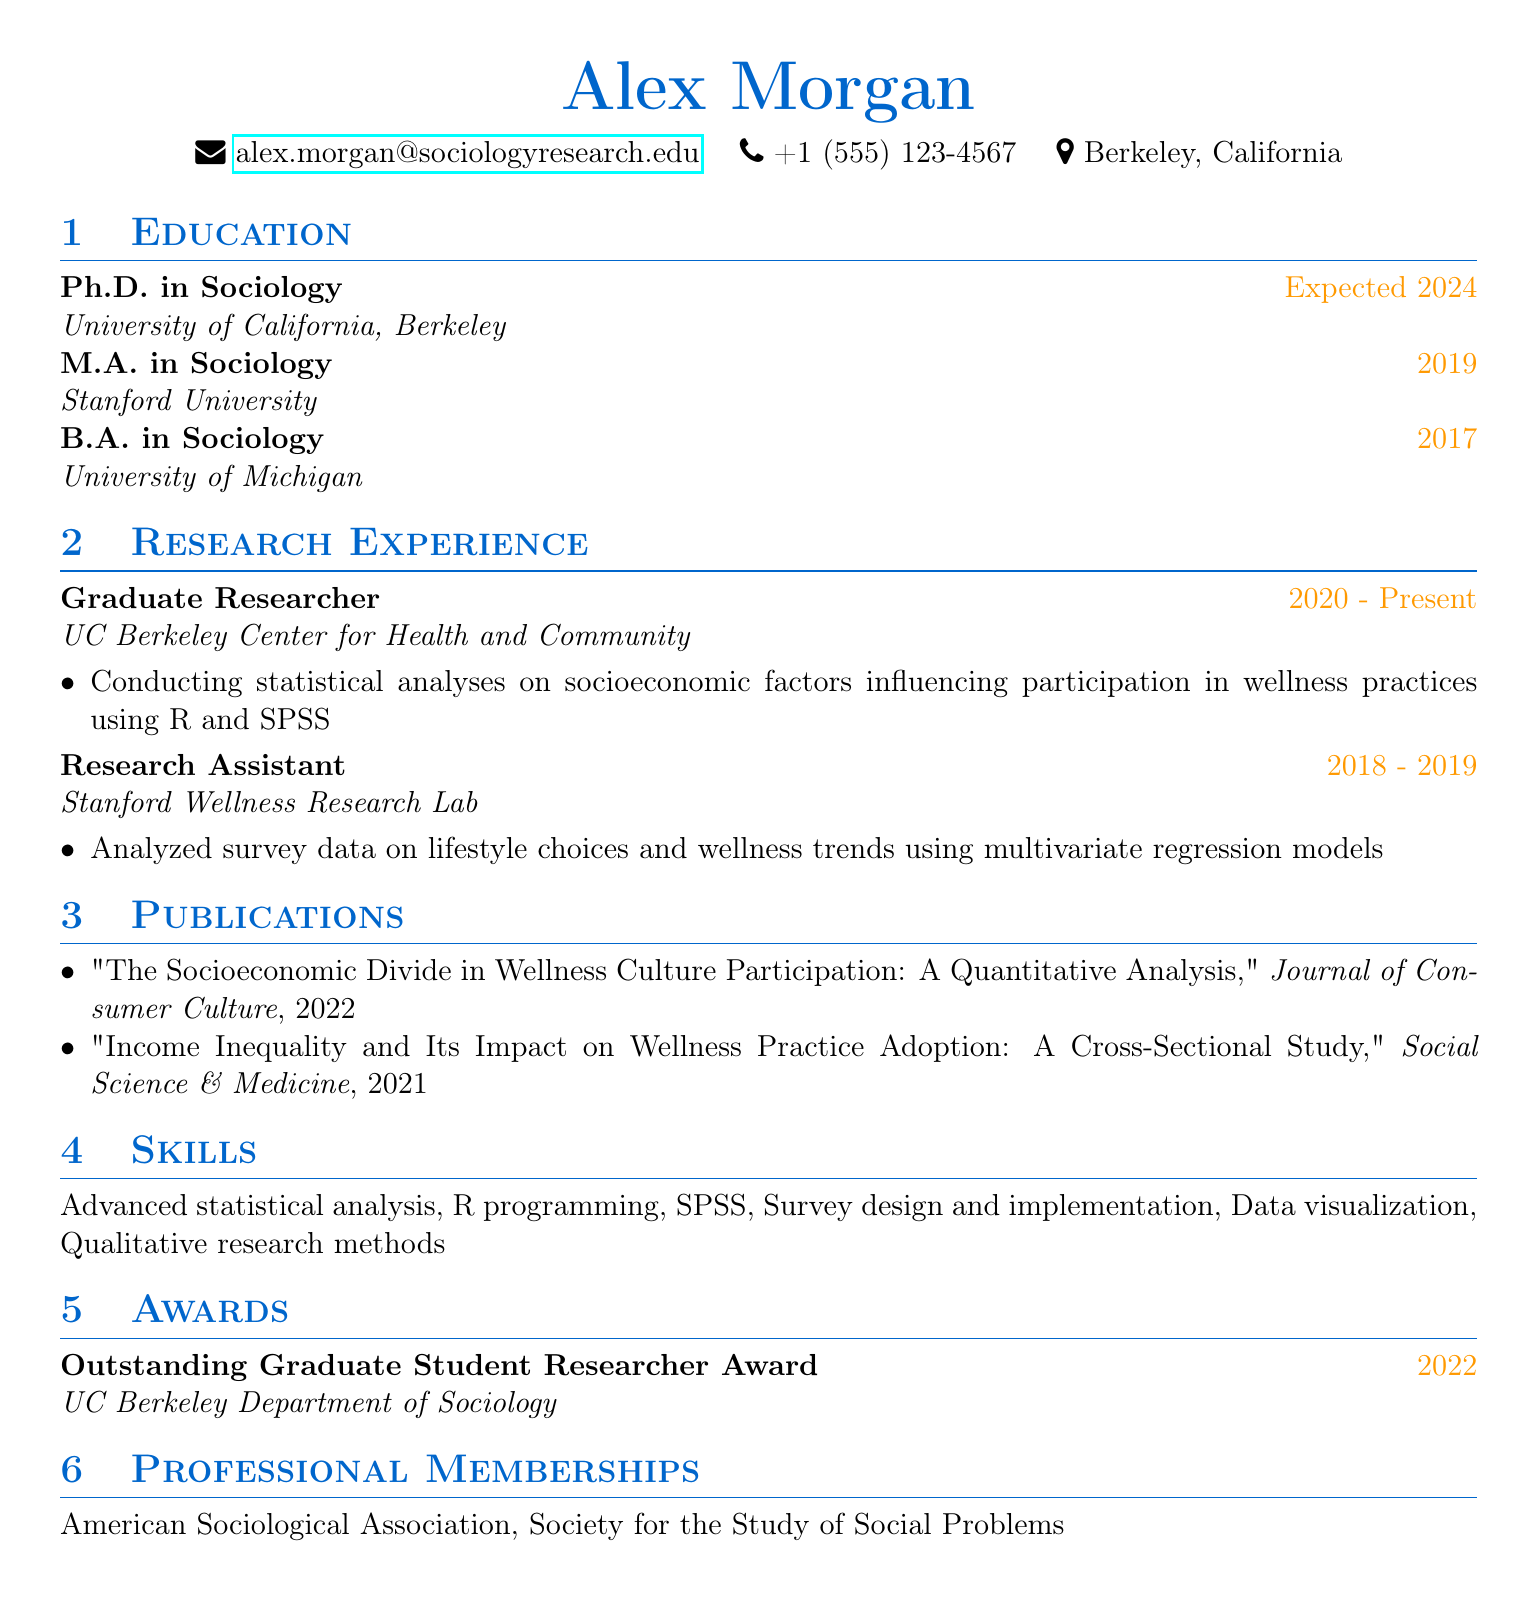what is the expected year of Ph.D. completion? The expected year of Ph.D. completion is specified in the education section of the CV.
Answer: 2024 which university did Alex Morgan attend for their M.A. in Sociology? The university attended for the M.A. is mentioned directly in the education section of the CV.
Answer: Stanford University what role did Alex Morgan hold at the UC Berkeley Center for Health and Community? The role is detailed in the research experience section of the CV.
Answer: Graduate Researcher how many years of research experience does Alex Morgan have? The duration of research roles is provided, indicating the total years of experience from the given positions.
Answer: 5 years name one statistical software that Alex Morgan is proficient in. The skills section lists specific software that the individual is familiar with.
Answer: R programming what topic did the publication in the Journal of Consumer Culture discuss? The title of the publication indicates the main subject matter addressed in the publication.
Answer: Socioeconomic Divide in Wellness Culture Participation what award did Alex Morgan receive in 2022? The awards section specifies the recognition received by Alex Morgan in that year.
Answer: Outstanding Graduate Student Researcher Award which professional association is Alex Morgan a member of? The professional memberships section lists organizations that Alex Morgan is affiliated with.
Answer: American Sociological Association what is the focus of Alex Morgan's research? The description of research roles highlights the overall area of focus for their work.
Answer: Socioeconomic factors influencing participation in wellness practices 